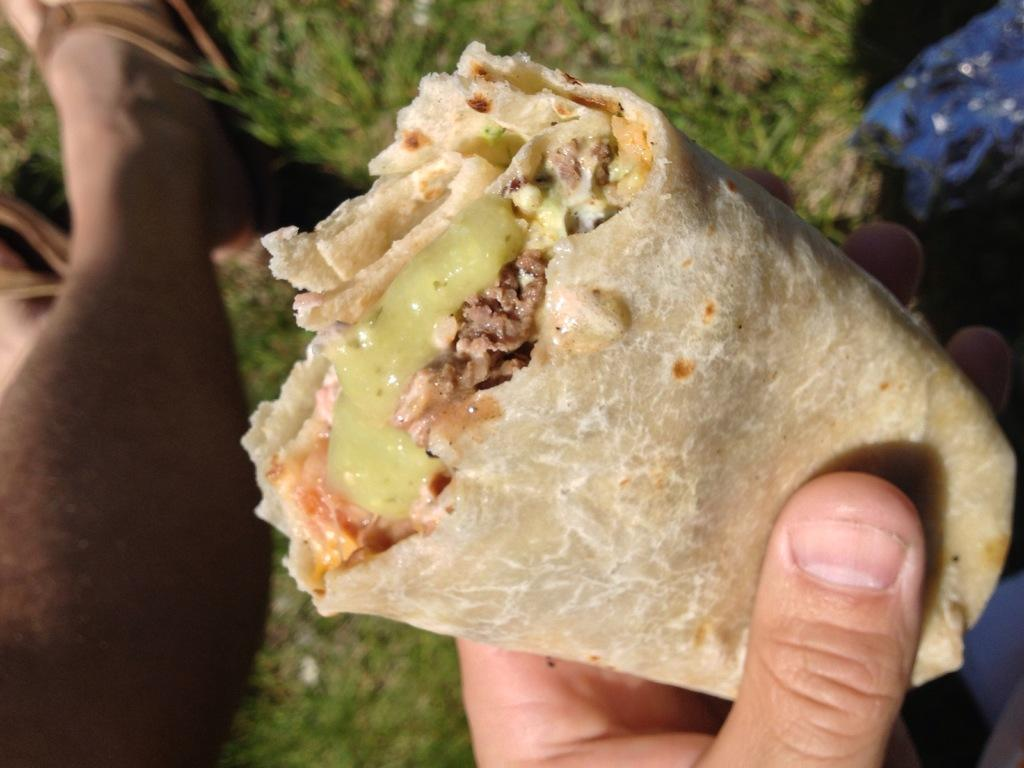What is the main object in the image? There is a tortilla in the image. What is the tortilla's position in the image? A person is holding the tortilla. Can you describe any part of the person holding the tortilla? There is a leg of a person visible in the image. What type of light is being used to illuminate the tortilla in the image? There is no specific light source mentioned or visible in the image, so it cannot be determined what type of light is being used. 